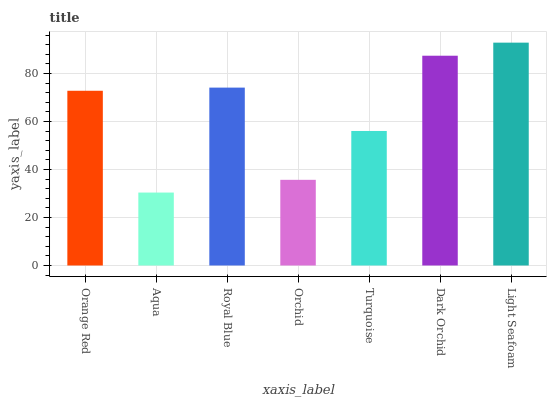Is Aqua the minimum?
Answer yes or no. Yes. Is Light Seafoam the maximum?
Answer yes or no. Yes. Is Royal Blue the minimum?
Answer yes or no. No. Is Royal Blue the maximum?
Answer yes or no. No. Is Royal Blue greater than Aqua?
Answer yes or no. Yes. Is Aqua less than Royal Blue?
Answer yes or no. Yes. Is Aqua greater than Royal Blue?
Answer yes or no. No. Is Royal Blue less than Aqua?
Answer yes or no. No. Is Orange Red the high median?
Answer yes or no. Yes. Is Orange Red the low median?
Answer yes or no. Yes. Is Turquoise the high median?
Answer yes or no. No. Is Dark Orchid the low median?
Answer yes or no. No. 